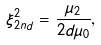Convert formula to latex. <formula><loc_0><loc_0><loc_500><loc_500>\xi _ { 2 n d } ^ { 2 } = \frac { \mu _ { 2 } } { 2 d \mu _ { 0 } } ,</formula> 